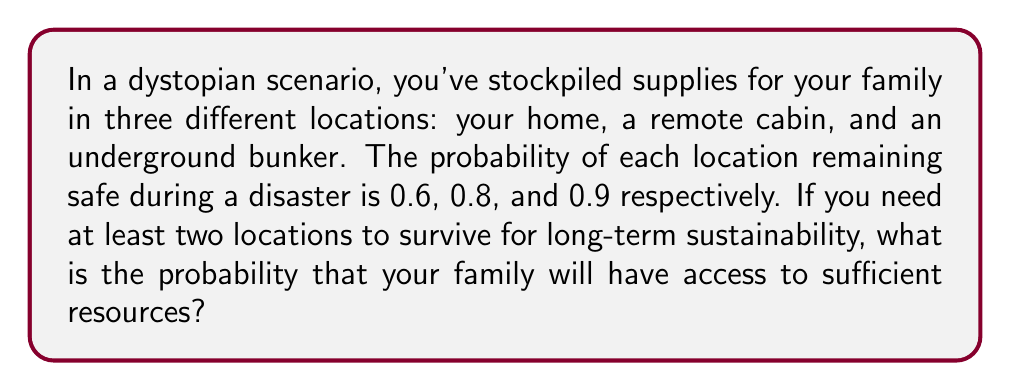Give your solution to this math problem. Let's approach this step-by-step using probability theory:

1) First, let's define our events:
   A: Home remains safe (P(A) = 0.6)
   B: Cabin remains safe (P(B) = 0.8)
   C: Bunker remains safe (P(C) = 0.9)

2) We need to calculate the probability of at least two locations remaining safe. It's easier to calculate the complement of this event (i.e., the probability of 0 or 1 location remaining safe) and subtract it from 1.

3) Probability of 0 locations remaining safe:
   $P(\text{none}) = (1-0.6)(1-0.8)(1-0.9) = 0.4 \times 0.2 \times 0.1 = 0.008$

4) Probability of exactly 1 location remaining safe:
   $P(\text{only A}) = 0.6 \times 0.2 \times 0.1 = 0.012$
   $P(\text{only B}) = 0.4 \times 0.8 \times 0.1 = 0.032$
   $P(\text{only C}) = 0.4 \times 0.2 \times 0.9 = 0.072$
   
   $P(\text{exactly one}) = 0.012 + 0.032 + 0.072 = 0.116$

5) Probability of 0 or 1 location remaining safe:
   $P(0 \text{ or } 1) = 0.008 + 0.116 = 0.124$

6) Therefore, the probability of at least 2 locations remaining safe:
   $P(\text{at least 2}) = 1 - P(0 \text{ or } 1) = 1 - 0.124 = 0.876$

Thus, the probability that your family will have access to sufficient resources is 0.876 or 87.6%.
Answer: 0.876 